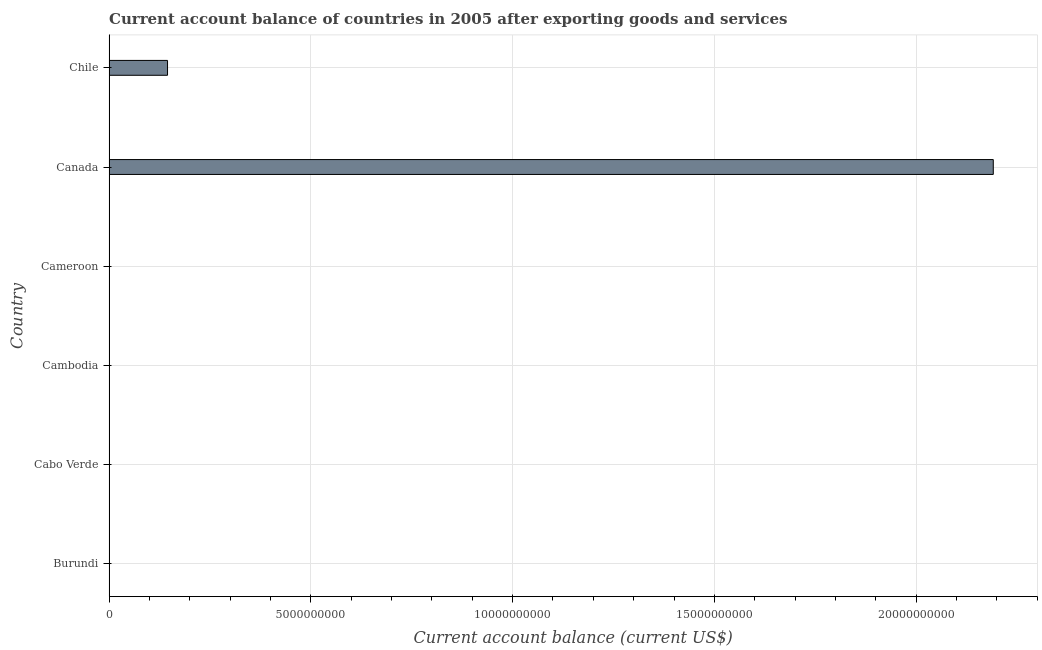Does the graph contain grids?
Your response must be concise. Yes. What is the title of the graph?
Your response must be concise. Current account balance of countries in 2005 after exporting goods and services. What is the label or title of the X-axis?
Make the answer very short. Current account balance (current US$). What is the label or title of the Y-axis?
Your response must be concise. Country. What is the current account balance in Burundi?
Keep it short and to the point. 0. Across all countries, what is the maximum current account balance?
Ensure brevity in your answer.  2.19e+1. Across all countries, what is the minimum current account balance?
Offer a very short reply. 0. What is the sum of the current account balance?
Make the answer very short. 2.34e+1. What is the average current account balance per country?
Your answer should be very brief. 3.89e+09. In how many countries, is the current account balance greater than 11000000000 US$?
Give a very brief answer. 1. What is the ratio of the current account balance in Canada to that in Chile?
Give a very brief answer. 15.12. What is the difference between the highest and the lowest current account balance?
Keep it short and to the point. 2.19e+1. What is the Current account balance (current US$) in Cambodia?
Give a very brief answer. 0. What is the Current account balance (current US$) of Cameroon?
Keep it short and to the point. 0. What is the Current account balance (current US$) of Canada?
Ensure brevity in your answer.  2.19e+1. What is the Current account balance (current US$) in Chile?
Keep it short and to the point. 1.45e+09. What is the difference between the Current account balance (current US$) in Canada and Chile?
Your response must be concise. 2.05e+1. What is the ratio of the Current account balance (current US$) in Canada to that in Chile?
Your answer should be very brief. 15.12. 